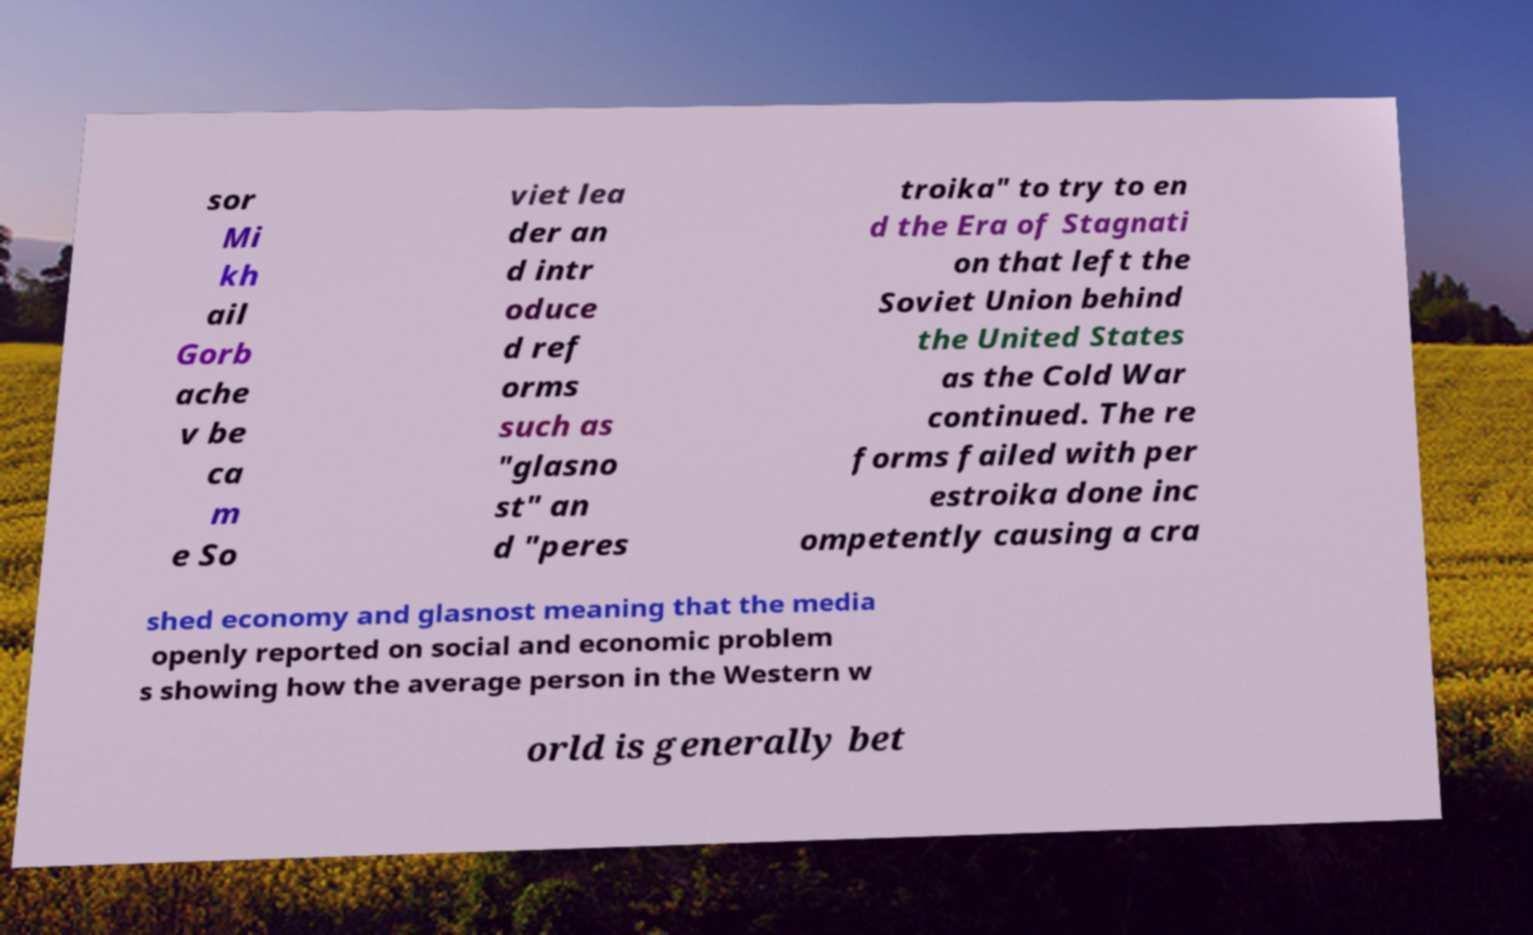What messages or text are displayed in this image? I need them in a readable, typed format. sor Mi kh ail Gorb ache v be ca m e So viet lea der an d intr oduce d ref orms such as "glasno st" an d "peres troika" to try to en d the Era of Stagnati on that left the Soviet Union behind the United States as the Cold War continued. The re forms failed with per estroika done inc ompetently causing a cra shed economy and glasnost meaning that the media openly reported on social and economic problem s showing how the average person in the Western w orld is generally bet 